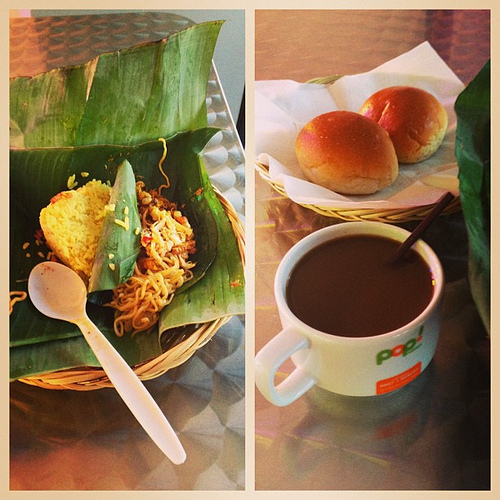How would you describe the atmosphere or setting this meal is prepared for? This meal exudes a laid-back, homestyle atmosphere, pairing simple, heartwarming dishes such as noodles and bread buns with a casual coffee, creating a sense of comfort and ease—a perfect setting for a relaxed, no-frills dining experience. 